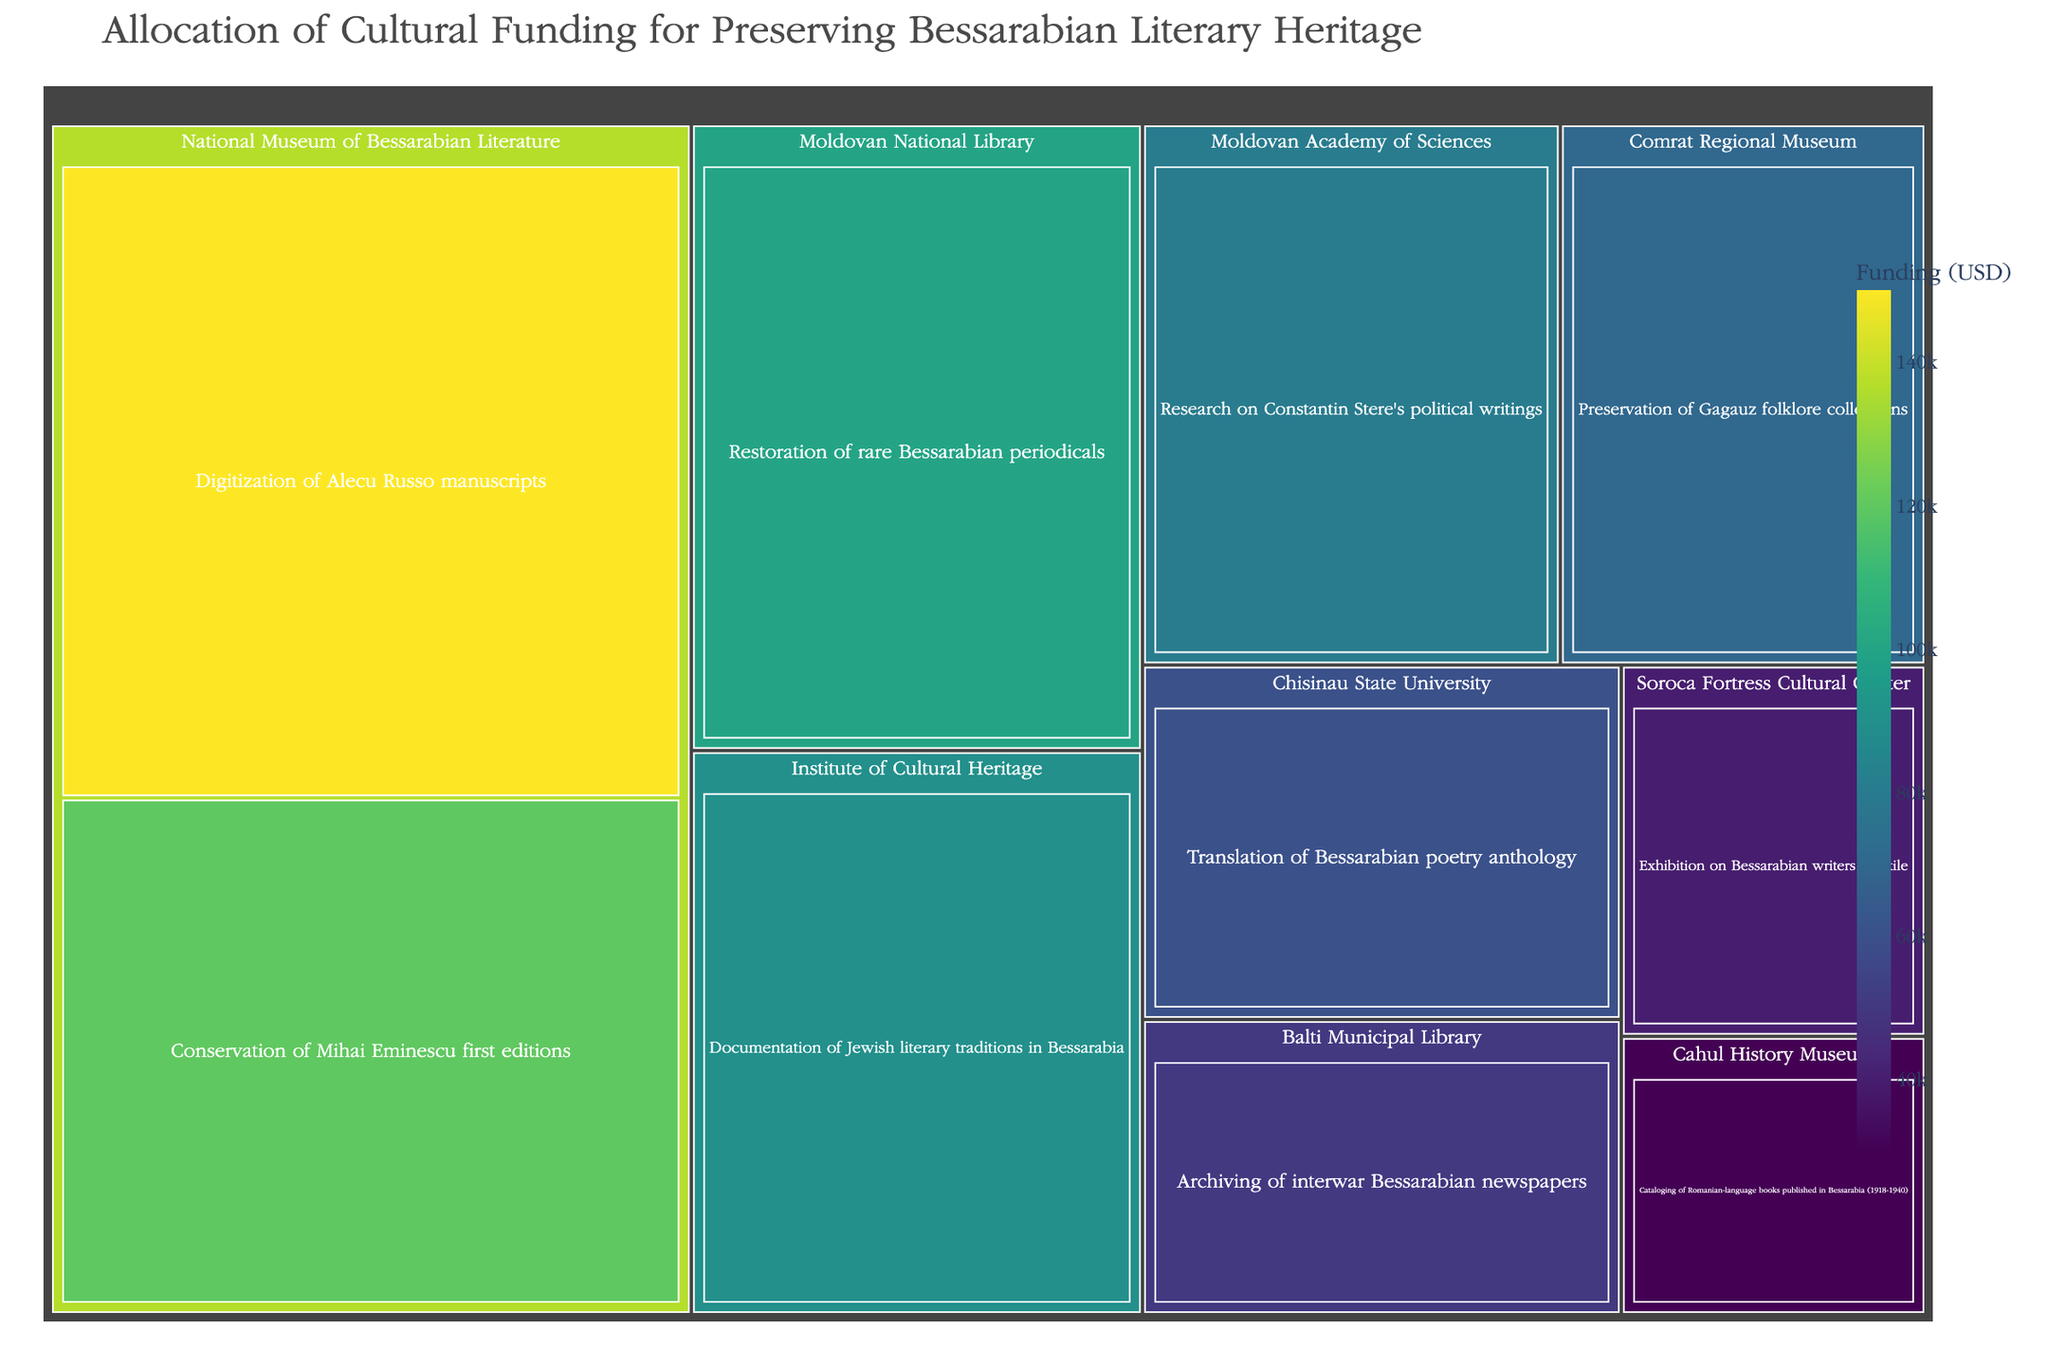What is the total amount of funding allocated to the National Museum of Bessarabian Literature? Look at the treemap, find all funding values under the National Museum of Bessarabian Literature, and sum them up. The values are $150,000 and $120,000. Therefore, the total is $150,000 + $120,000.
Answer: $270,000 Which institution received the highest funding for a single project? Look at all the projects and their corresponding funding values. The project with the highest funding is $150,000 for the Digitization of Alecu Russo manuscripts at the National Museum of Bessarabian Literature.
Answer: National Museum of Bessarabian Literature How many projects are focused on preserving periodicals and newspapers? Identify the projects related to periodicals and newspapers. These are the Restoration of rare Bessarabian periodicals by the Moldovan National Library and the Archiving of interwar Bessarabian newspapers by the Balti Municipal Library.
Answer: 2 Which institution focuses on the preservation of Gagauz folklore collections? Look at the treemap for the project related to the Gagauz folklore collections. This is the Preservation of Gagauz folklore collections by the Comrat Regional Museum.
Answer: Comrat Regional Museum What is the total funding for all projects managed by universities? Identify and sum the funding values for projects under the Chisinau State University and any other universities. The values are $60,000 for the Translation of Bessarabian poetry anthology.
Answer: $60,000 Compare the funding for the Digitization of Alecu Russo manuscripts to the Restoration of rare Bessarabian periodicals. Which project received more funding and by how much? Look at the funding values for both projects: $150,000 for Digitization of Alecu Russo manuscripts and $100,000 for Restoration of rare Bessarabian periodicals. The difference is $150,000 - $100,000.
Answer: Digitization of Alecu Russo manuscripts received $50,000 more Which project at the Institute of Cultural Heritage received funding, and how much was it? Locate the Institute of Cultural Heritage in the treemap, and identify the associated project and its funding. The project is the Documentation of Jewish literary traditions in Bessarabia, with funding of $90,000.
Answer: Documentation of Jewish literary traditions in Bessarabia received $90,000 What is the smallest amount of funding allocated for a single project, and which project received it? Look at all the funding values in the treemap and find the smallest one. The smallest value is $30,000 for the Cataloging of Romanian-language books published in Bessarabia (1918-1940) by the Cahul History Museum.
Answer: $30,000 for Cataloging of Romanian-language books Which project focusing on Bessarabian writers in exile received funding, and which institution manages it? Identify the project related to Bessarabian writers in exile. The project is the Exhibition on Bessarabian writers in exile, managed by the Soroca Fortress Cultural Center.
Answer: Exhibition on Bessarabian writers in exile by Soroca Fortress Cultural Center 